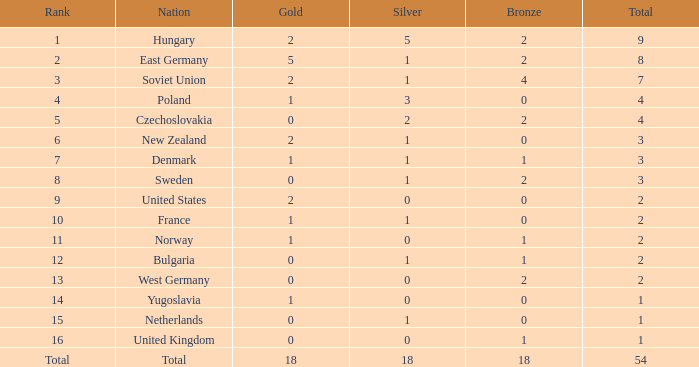What is the lowest total for those receiving less than 18 but more than 14? 1.0. 